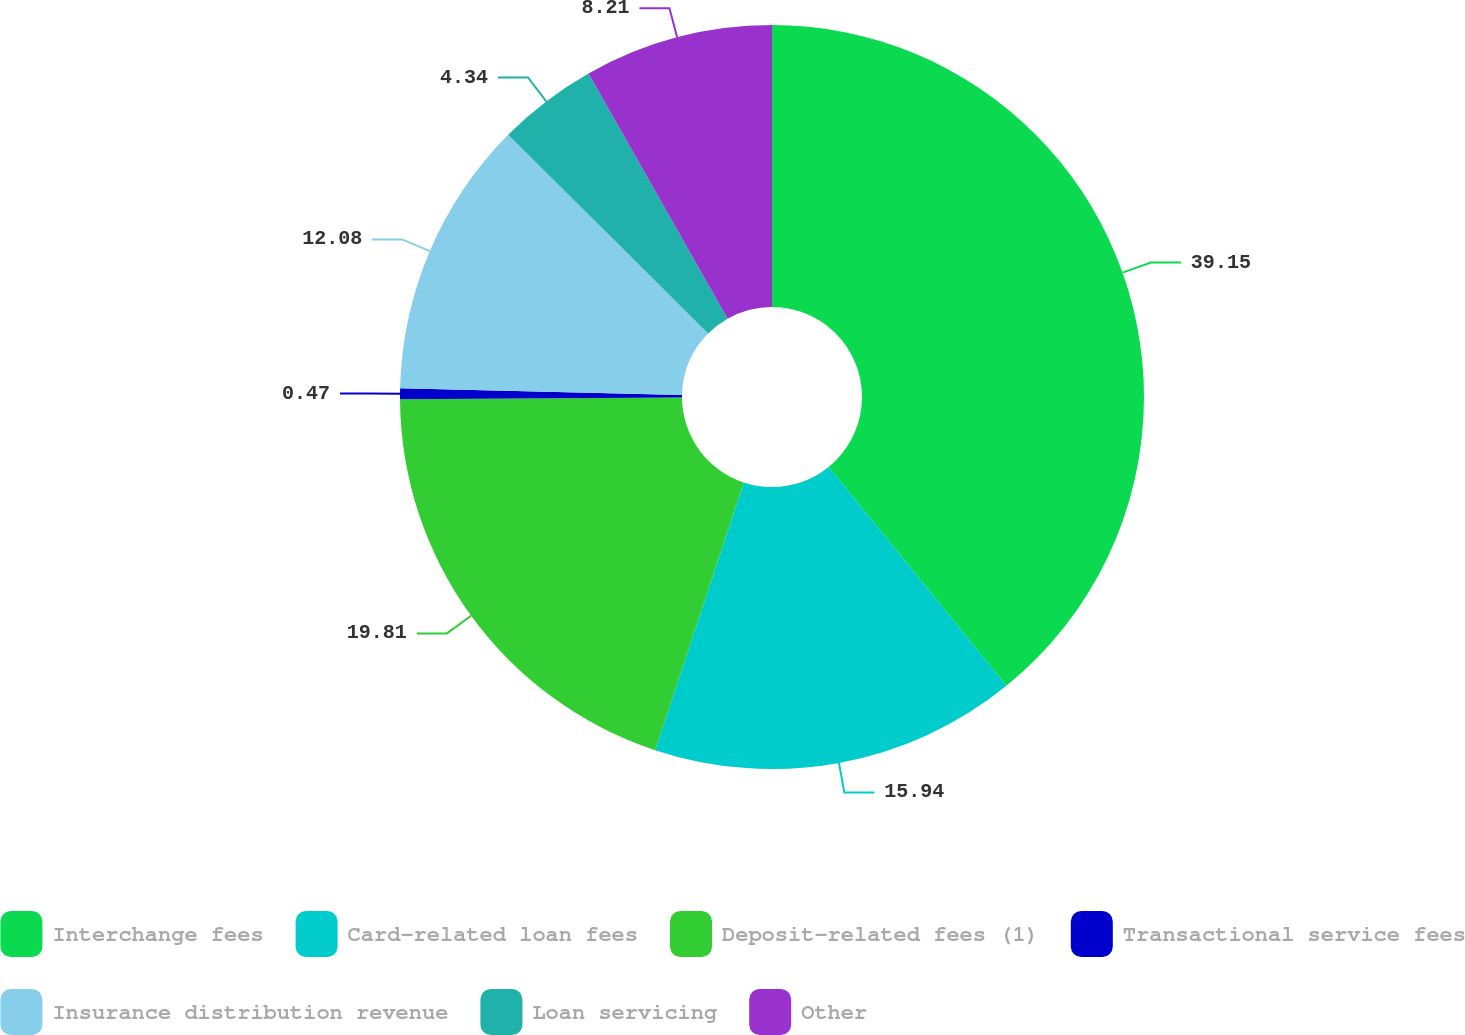Convert chart. <chart><loc_0><loc_0><loc_500><loc_500><pie_chart><fcel>Interchange fees<fcel>Card-related loan fees<fcel>Deposit-related fees (1)<fcel>Transactional service fees<fcel>Insurance distribution revenue<fcel>Loan servicing<fcel>Other<nl><fcel>39.15%<fcel>15.94%<fcel>19.81%<fcel>0.47%<fcel>12.08%<fcel>4.34%<fcel>8.21%<nl></chart> 